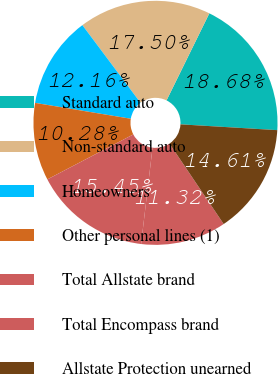<chart> <loc_0><loc_0><loc_500><loc_500><pie_chart><fcel>Standard auto<fcel>Non-standard auto<fcel>Homeowners<fcel>Other personal lines (1)<fcel>Total Allstate brand<fcel>Total Encompass brand<fcel>Allstate Protection unearned<nl><fcel>18.68%<fcel>17.5%<fcel>12.16%<fcel>10.28%<fcel>15.45%<fcel>11.32%<fcel>14.61%<nl></chart> 